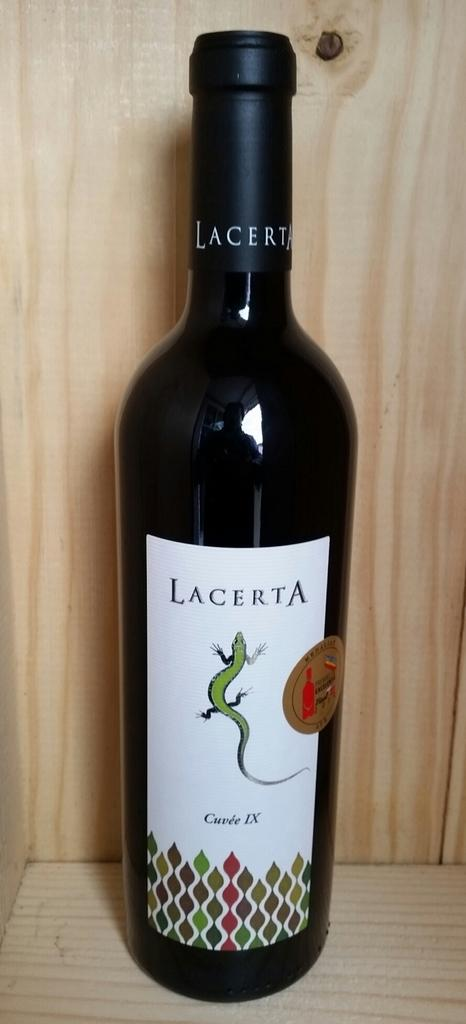<image>
Provide a brief description of the given image. A wooden table or box,and a wine bottle with a lizard and the name Lacerta 